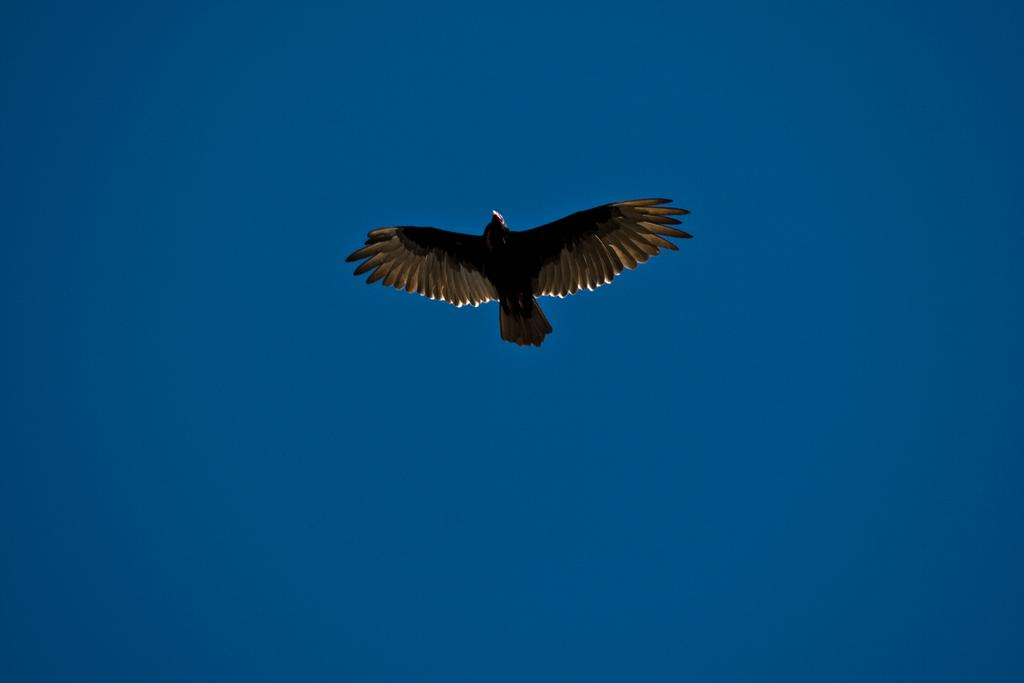What type of animal can be seen in the image? There is a bird in the image. What is the bird doing in the image? The bird is flying. What can be seen in the background of the image? The sky is visible in the background of the image. What type of rule is being enforced by the bird in the image? There is no rule being enforced by the bird in the image; it is simply flying. Are there any stockings visible on the bird in the image? There are no stockings present on the bird in the image. 